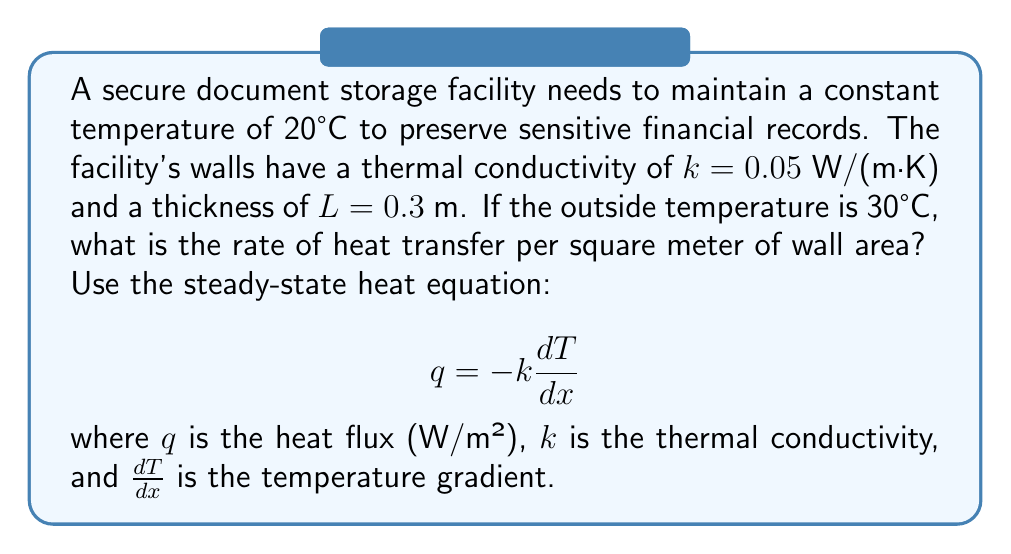Solve this math problem. Let's approach this step-by-step:

1) We are given:
   - Inside temperature $T_1 = 20°C$
   - Outside temperature $T_2 = 30°C$
   - Thermal conductivity $k = 0.05$ W/(m·K)
   - Wall thickness $L = 0.3$ m

2) For steady-state heat conduction through a plane wall, we can simplify the heat equation to:

   $$ q = k \frac{T_2 - T_1}{L} $$

3) Note that we've removed the negative sign because we're calculating the magnitude of heat flux.

4) Now, let's substitute our values:

   $$ q = 0.05 \frac{30 - 20}{0.3} $$

5) Simplify:
   
   $$ q = 0.05 \frac{10}{0.3} = 0.05 \cdot \frac{100}{3} $$

6) Calculate the final result:

   $$ q = \frac{5}{3} \approx 1.667 \text{ W/m²} $$

This means that for every square meter of wall area, approximately 1.667 watts of heat are transferred from the outside to the inside of the facility.
Answer: $1.667 \text{ W/m²}$ 